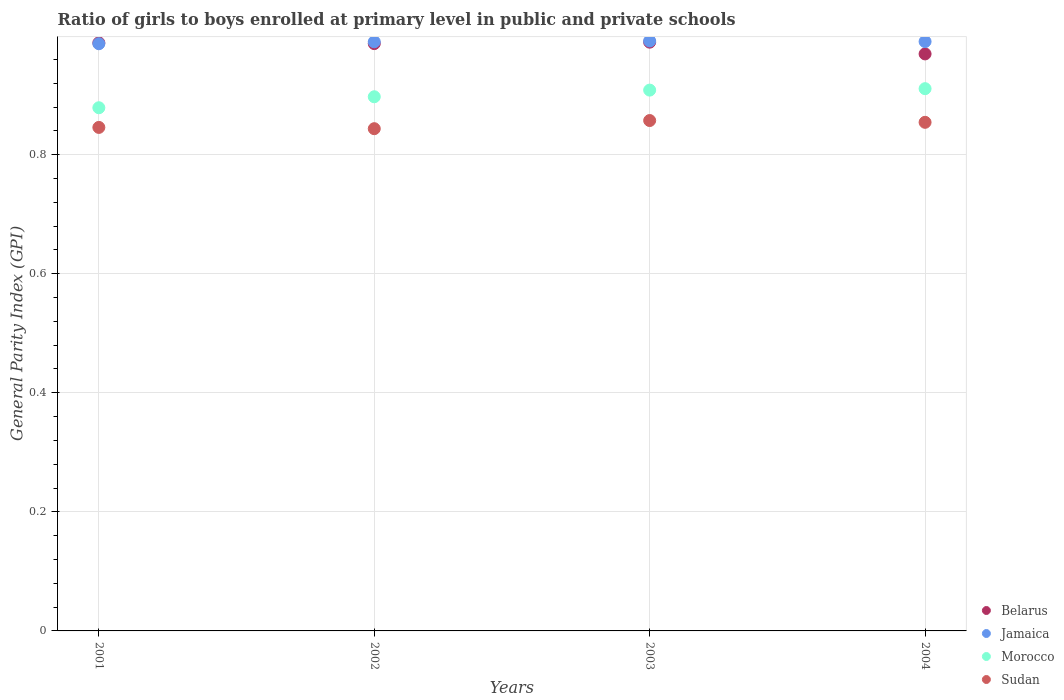Is the number of dotlines equal to the number of legend labels?
Keep it short and to the point. Yes. What is the general parity index in Jamaica in 2004?
Your answer should be compact. 0.99. Across all years, what is the maximum general parity index in Jamaica?
Provide a short and direct response. 0.99. Across all years, what is the minimum general parity index in Jamaica?
Your response must be concise. 0.99. What is the total general parity index in Jamaica in the graph?
Provide a succinct answer. 3.96. What is the difference between the general parity index in Sudan in 2002 and that in 2004?
Give a very brief answer. -0.01. What is the difference between the general parity index in Morocco in 2003 and the general parity index in Jamaica in 2001?
Your answer should be compact. -0.08. What is the average general parity index in Jamaica per year?
Your answer should be very brief. 0.99. In the year 2003, what is the difference between the general parity index in Jamaica and general parity index in Sudan?
Ensure brevity in your answer.  0.13. What is the ratio of the general parity index in Morocco in 2002 to that in 2004?
Your answer should be compact. 0.99. Is the difference between the general parity index in Jamaica in 2002 and 2003 greater than the difference between the general parity index in Sudan in 2002 and 2003?
Make the answer very short. Yes. What is the difference between the highest and the second highest general parity index in Sudan?
Your answer should be compact. 0. What is the difference between the highest and the lowest general parity index in Jamaica?
Offer a very short reply. 0. Is the sum of the general parity index in Sudan in 2003 and 2004 greater than the maximum general parity index in Morocco across all years?
Give a very brief answer. Yes. Is it the case that in every year, the sum of the general parity index in Morocco and general parity index in Belarus  is greater than the general parity index in Jamaica?
Your answer should be compact. Yes. Is the general parity index in Jamaica strictly greater than the general parity index in Belarus over the years?
Make the answer very short. No. What is the difference between two consecutive major ticks on the Y-axis?
Ensure brevity in your answer.  0.2. Are the values on the major ticks of Y-axis written in scientific E-notation?
Offer a very short reply. No. Does the graph contain any zero values?
Ensure brevity in your answer.  No. What is the title of the graph?
Your answer should be compact. Ratio of girls to boys enrolled at primary level in public and private schools. What is the label or title of the X-axis?
Provide a short and direct response. Years. What is the label or title of the Y-axis?
Give a very brief answer. General Parity Index (GPI). What is the General Parity Index (GPI) in Belarus in 2001?
Your answer should be very brief. 0.99. What is the General Parity Index (GPI) of Jamaica in 2001?
Ensure brevity in your answer.  0.99. What is the General Parity Index (GPI) of Morocco in 2001?
Provide a succinct answer. 0.88. What is the General Parity Index (GPI) of Sudan in 2001?
Provide a short and direct response. 0.85. What is the General Parity Index (GPI) of Belarus in 2002?
Provide a short and direct response. 0.99. What is the General Parity Index (GPI) in Jamaica in 2002?
Your answer should be very brief. 0.99. What is the General Parity Index (GPI) in Morocco in 2002?
Give a very brief answer. 0.9. What is the General Parity Index (GPI) in Sudan in 2002?
Provide a succinct answer. 0.84. What is the General Parity Index (GPI) of Belarus in 2003?
Provide a succinct answer. 0.99. What is the General Parity Index (GPI) in Jamaica in 2003?
Your response must be concise. 0.99. What is the General Parity Index (GPI) in Morocco in 2003?
Provide a succinct answer. 0.91. What is the General Parity Index (GPI) of Sudan in 2003?
Keep it short and to the point. 0.86. What is the General Parity Index (GPI) in Belarus in 2004?
Provide a succinct answer. 0.97. What is the General Parity Index (GPI) in Jamaica in 2004?
Your answer should be compact. 0.99. What is the General Parity Index (GPI) of Morocco in 2004?
Offer a very short reply. 0.91. What is the General Parity Index (GPI) in Sudan in 2004?
Keep it short and to the point. 0.85. Across all years, what is the maximum General Parity Index (GPI) in Belarus?
Make the answer very short. 0.99. Across all years, what is the maximum General Parity Index (GPI) of Jamaica?
Your answer should be very brief. 0.99. Across all years, what is the maximum General Parity Index (GPI) in Morocco?
Keep it short and to the point. 0.91. Across all years, what is the maximum General Parity Index (GPI) in Sudan?
Provide a short and direct response. 0.86. Across all years, what is the minimum General Parity Index (GPI) in Belarus?
Your answer should be very brief. 0.97. Across all years, what is the minimum General Parity Index (GPI) in Jamaica?
Provide a short and direct response. 0.99. Across all years, what is the minimum General Parity Index (GPI) of Morocco?
Your answer should be very brief. 0.88. Across all years, what is the minimum General Parity Index (GPI) of Sudan?
Provide a short and direct response. 0.84. What is the total General Parity Index (GPI) in Belarus in the graph?
Keep it short and to the point. 3.93. What is the total General Parity Index (GPI) in Jamaica in the graph?
Offer a very short reply. 3.96. What is the total General Parity Index (GPI) in Morocco in the graph?
Your response must be concise. 3.6. What is the total General Parity Index (GPI) of Sudan in the graph?
Your answer should be compact. 3.4. What is the difference between the General Parity Index (GPI) of Belarus in 2001 and that in 2002?
Ensure brevity in your answer.  0. What is the difference between the General Parity Index (GPI) of Jamaica in 2001 and that in 2002?
Give a very brief answer. -0. What is the difference between the General Parity Index (GPI) in Morocco in 2001 and that in 2002?
Your answer should be very brief. -0.02. What is the difference between the General Parity Index (GPI) in Sudan in 2001 and that in 2002?
Provide a short and direct response. 0. What is the difference between the General Parity Index (GPI) in Belarus in 2001 and that in 2003?
Your response must be concise. -0. What is the difference between the General Parity Index (GPI) of Jamaica in 2001 and that in 2003?
Provide a short and direct response. -0. What is the difference between the General Parity Index (GPI) in Morocco in 2001 and that in 2003?
Ensure brevity in your answer.  -0.03. What is the difference between the General Parity Index (GPI) in Sudan in 2001 and that in 2003?
Your response must be concise. -0.01. What is the difference between the General Parity Index (GPI) of Belarus in 2001 and that in 2004?
Keep it short and to the point. 0.02. What is the difference between the General Parity Index (GPI) in Jamaica in 2001 and that in 2004?
Your response must be concise. -0. What is the difference between the General Parity Index (GPI) of Morocco in 2001 and that in 2004?
Offer a terse response. -0.03. What is the difference between the General Parity Index (GPI) in Sudan in 2001 and that in 2004?
Offer a very short reply. -0.01. What is the difference between the General Parity Index (GPI) of Belarus in 2002 and that in 2003?
Your response must be concise. -0. What is the difference between the General Parity Index (GPI) in Jamaica in 2002 and that in 2003?
Offer a terse response. -0. What is the difference between the General Parity Index (GPI) of Morocco in 2002 and that in 2003?
Provide a succinct answer. -0.01. What is the difference between the General Parity Index (GPI) of Sudan in 2002 and that in 2003?
Provide a succinct answer. -0.01. What is the difference between the General Parity Index (GPI) in Belarus in 2002 and that in 2004?
Ensure brevity in your answer.  0.02. What is the difference between the General Parity Index (GPI) of Jamaica in 2002 and that in 2004?
Give a very brief answer. -0. What is the difference between the General Parity Index (GPI) in Morocco in 2002 and that in 2004?
Give a very brief answer. -0.01. What is the difference between the General Parity Index (GPI) in Sudan in 2002 and that in 2004?
Provide a succinct answer. -0.01. What is the difference between the General Parity Index (GPI) of Belarus in 2003 and that in 2004?
Make the answer very short. 0.02. What is the difference between the General Parity Index (GPI) of Morocco in 2003 and that in 2004?
Offer a terse response. -0. What is the difference between the General Parity Index (GPI) of Sudan in 2003 and that in 2004?
Offer a very short reply. 0. What is the difference between the General Parity Index (GPI) in Belarus in 2001 and the General Parity Index (GPI) in Jamaica in 2002?
Your response must be concise. -0. What is the difference between the General Parity Index (GPI) of Belarus in 2001 and the General Parity Index (GPI) of Morocco in 2002?
Provide a short and direct response. 0.09. What is the difference between the General Parity Index (GPI) of Belarus in 2001 and the General Parity Index (GPI) of Sudan in 2002?
Provide a succinct answer. 0.14. What is the difference between the General Parity Index (GPI) of Jamaica in 2001 and the General Parity Index (GPI) of Morocco in 2002?
Keep it short and to the point. 0.09. What is the difference between the General Parity Index (GPI) in Jamaica in 2001 and the General Parity Index (GPI) in Sudan in 2002?
Offer a terse response. 0.14. What is the difference between the General Parity Index (GPI) of Morocco in 2001 and the General Parity Index (GPI) of Sudan in 2002?
Provide a succinct answer. 0.04. What is the difference between the General Parity Index (GPI) of Belarus in 2001 and the General Parity Index (GPI) of Jamaica in 2003?
Keep it short and to the point. -0. What is the difference between the General Parity Index (GPI) of Belarus in 2001 and the General Parity Index (GPI) of Morocco in 2003?
Your answer should be compact. 0.08. What is the difference between the General Parity Index (GPI) in Belarus in 2001 and the General Parity Index (GPI) in Sudan in 2003?
Make the answer very short. 0.13. What is the difference between the General Parity Index (GPI) in Jamaica in 2001 and the General Parity Index (GPI) in Morocco in 2003?
Ensure brevity in your answer.  0.08. What is the difference between the General Parity Index (GPI) of Jamaica in 2001 and the General Parity Index (GPI) of Sudan in 2003?
Provide a short and direct response. 0.13. What is the difference between the General Parity Index (GPI) of Morocco in 2001 and the General Parity Index (GPI) of Sudan in 2003?
Keep it short and to the point. 0.02. What is the difference between the General Parity Index (GPI) in Belarus in 2001 and the General Parity Index (GPI) in Jamaica in 2004?
Your answer should be compact. -0. What is the difference between the General Parity Index (GPI) in Belarus in 2001 and the General Parity Index (GPI) in Morocco in 2004?
Offer a terse response. 0.08. What is the difference between the General Parity Index (GPI) in Belarus in 2001 and the General Parity Index (GPI) in Sudan in 2004?
Your answer should be compact. 0.13. What is the difference between the General Parity Index (GPI) of Jamaica in 2001 and the General Parity Index (GPI) of Morocco in 2004?
Offer a terse response. 0.08. What is the difference between the General Parity Index (GPI) of Jamaica in 2001 and the General Parity Index (GPI) of Sudan in 2004?
Your answer should be compact. 0.13. What is the difference between the General Parity Index (GPI) of Morocco in 2001 and the General Parity Index (GPI) of Sudan in 2004?
Your response must be concise. 0.02. What is the difference between the General Parity Index (GPI) of Belarus in 2002 and the General Parity Index (GPI) of Jamaica in 2003?
Offer a terse response. -0. What is the difference between the General Parity Index (GPI) in Belarus in 2002 and the General Parity Index (GPI) in Morocco in 2003?
Your answer should be very brief. 0.08. What is the difference between the General Parity Index (GPI) in Belarus in 2002 and the General Parity Index (GPI) in Sudan in 2003?
Your response must be concise. 0.13. What is the difference between the General Parity Index (GPI) in Jamaica in 2002 and the General Parity Index (GPI) in Morocco in 2003?
Offer a very short reply. 0.08. What is the difference between the General Parity Index (GPI) of Jamaica in 2002 and the General Parity Index (GPI) of Sudan in 2003?
Keep it short and to the point. 0.13. What is the difference between the General Parity Index (GPI) of Morocco in 2002 and the General Parity Index (GPI) of Sudan in 2003?
Give a very brief answer. 0.04. What is the difference between the General Parity Index (GPI) of Belarus in 2002 and the General Parity Index (GPI) of Jamaica in 2004?
Give a very brief answer. -0. What is the difference between the General Parity Index (GPI) of Belarus in 2002 and the General Parity Index (GPI) of Morocco in 2004?
Your answer should be compact. 0.08. What is the difference between the General Parity Index (GPI) of Belarus in 2002 and the General Parity Index (GPI) of Sudan in 2004?
Your answer should be compact. 0.13. What is the difference between the General Parity Index (GPI) in Jamaica in 2002 and the General Parity Index (GPI) in Morocco in 2004?
Provide a succinct answer. 0.08. What is the difference between the General Parity Index (GPI) in Jamaica in 2002 and the General Parity Index (GPI) in Sudan in 2004?
Give a very brief answer. 0.14. What is the difference between the General Parity Index (GPI) of Morocco in 2002 and the General Parity Index (GPI) of Sudan in 2004?
Provide a succinct answer. 0.04. What is the difference between the General Parity Index (GPI) of Belarus in 2003 and the General Parity Index (GPI) of Jamaica in 2004?
Make the answer very short. -0. What is the difference between the General Parity Index (GPI) in Belarus in 2003 and the General Parity Index (GPI) in Morocco in 2004?
Your answer should be very brief. 0.08. What is the difference between the General Parity Index (GPI) in Belarus in 2003 and the General Parity Index (GPI) in Sudan in 2004?
Keep it short and to the point. 0.13. What is the difference between the General Parity Index (GPI) of Jamaica in 2003 and the General Parity Index (GPI) of Morocco in 2004?
Provide a succinct answer. 0.08. What is the difference between the General Parity Index (GPI) of Jamaica in 2003 and the General Parity Index (GPI) of Sudan in 2004?
Make the answer very short. 0.14. What is the difference between the General Parity Index (GPI) of Morocco in 2003 and the General Parity Index (GPI) of Sudan in 2004?
Ensure brevity in your answer.  0.05. What is the average General Parity Index (GPI) of Belarus per year?
Make the answer very short. 0.98. What is the average General Parity Index (GPI) of Morocco per year?
Provide a short and direct response. 0.9. What is the average General Parity Index (GPI) in Sudan per year?
Provide a short and direct response. 0.85. In the year 2001, what is the difference between the General Parity Index (GPI) in Belarus and General Parity Index (GPI) in Jamaica?
Your answer should be very brief. 0. In the year 2001, what is the difference between the General Parity Index (GPI) in Belarus and General Parity Index (GPI) in Morocco?
Offer a terse response. 0.11. In the year 2001, what is the difference between the General Parity Index (GPI) of Belarus and General Parity Index (GPI) of Sudan?
Offer a terse response. 0.14. In the year 2001, what is the difference between the General Parity Index (GPI) in Jamaica and General Parity Index (GPI) in Morocco?
Offer a terse response. 0.11. In the year 2001, what is the difference between the General Parity Index (GPI) of Jamaica and General Parity Index (GPI) of Sudan?
Provide a short and direct response. 0.14. In the year 2001, what is the difference between the General Parity Index (GPI) in Morocco and General Parity Index (GPI) in Sudan?
Your answer should be compact. 0.03. In the year 2002, what is the difference between the General Parity Index (GPI) in Belarus and General Parity Index (GPI) in Jamaica?
Your response must be concise. -0. In the year 2002, what is the difference between the General Parity Index (GPI) of Belarus and General Parity Index (GPI) of Morocco?
Provide a short and direct response. 0.09. In the year 2002, what is the difference between the General Parity Index (GPI) of Belarus and General Parity Index (GPI) of Sudan?
Give a very brief answer. 0.14. In the year 2002, what is the difference between the General Parity Index (GPI) of Jamaica and General Parity Index (GPI) of Morocco?
Ensure brevity in your answer.  0.09. In the year 2002, what is the difference between the General Parity Index (GPI) in Jamaica and General Parity Index (GPI) in Sudan?
Offer a terse response. 0.15. In the year 2002, what is the difference between the General Parity Index (GPI) in Morocco and General Parity Index (GPI) in Sudan?
Provide a short and direct response. 0.05. In the year 2003, what is the difference between the General Parity Index (GPI) of Belarus and General Parity Index (GPI) of Jamaica?
Offer a terse response. -0. In the year 2003, what is the difference between the General Parity Index (GPI) of Belarus and General Parity Index (GPI) of Morocco?
Ensure brevity in your answer.  0.08. In the year 2003, what is the difference between the General Parity Index (GPI) in Belarus and General Parity Index (GPI) in Sudan?
Ensure brevity in your answer.  0.13. In the year 2003, what is the difference between the General Parity Index (GPI) of Jamaica and General Parity Index (GPI) of Morocco?
Your answer should be very brief. 0.08. In the year 2003, what is the difference between the General Parity Index (GPI) of Jamaica and General Parity Index (GPI) of Sudan?
Provide a short and direct response. 0.13. In the year 2003, what is the difference between the General Parity Index (GPI) in Morocco and General Parity Index (GPI) in Sudan?
Your response must be concise. 0.05. In the year 2004, what is the difference between the General Parity Index (GPI) of Belarus and General Parity Index (GPI) of Jamaica?
Provide a short and direct response. -0.02. In the year 2004, what is the difference between the General Parity Index (GPI) of Belarus and General Parity Index (GPI) of Morocco?
Offer a very short reply. 0.06. In the year 2004, what is the difference between the General Parity Index (GPI) of Belarus and General Parity Index (GPI) of Sudan?
Ensure brevity in your answer.  0.11. In the year 2004, what is the difference between the General Parity Index (GPI) of Jamaica and General Parity Index (GPI) of Morocco?
Your answer should be compact. 0.08. In the year 2004, what is the difference between the General Parity Index (GPI) of Jamaica and General Parity Index (GPI) of Sudan?
Give a very brief answer. 0.14. In the year 2004, what is the difference between the General Parity Index (GPI) in Morocco and General Parity Index (GPI) in Sudan?
Your response must be concise. 0.06. What is the ratio of the General Parity Index (GPI) in Belarus in 2001 to that in 2002?
Offer a very short reply. 1. What is the ratio of the General Parity Index (GPI) of Morocco in 2001 to that in 2002?
Offer a very short reply. 0.98. What is the ratio of the General Parity Index (GPI) of Sudan in 2001 to that in 2002?
Offer a very short reply. 1. What is the ratio of the General Parity Index (GPI) in Belarus in 2001 to that in 2003?
Keep it short and to the point. 1. What is the ratio of the General Parity Index (GPI) of Jamaica in 2001 to that in 2003?
Keep it short and to the point. 1. What is the ratio of the General Parity Index (GPI) of Morocco in 2001 to that in 2003?
Keep it short and to the point. 0.97. What is the ratio of the General Parity Index (GPI) in Sudan in 2001 to that in 2003?
Your answer should be very brief. 0.99. What is the ratio of the General Parity Index (GPI) in Belarus in 2001 to that in 2004?
Offer a terse response. 1.02. What is the ratio of the General Parity Index (GPI) of Jamaica in 2001 to that in 2004?
Ensure brevity in your answer.  1. What is the ratio of the General Parity Index (GPI) in Morocco in 2001 to that in 2004?
Keep it short and to the point. 0.96. What is the ratio of the General Parity Index (GPI) of Belarus in 2002 to that in 2003?
Provide a succinct answer. 1. What is the ratio of the General Parity Index (GPI) in Sudan in 2002 to that in 2003?
Your answer should be very brief. 0.98. What is the ratio of the General Parity Index (GPI) in Belarus in 2002 to that in 2004?
Offer a terse response. 1.02. What is the ratio of the General Parity Index (GPI) of Morocco in 2002 to that in 2004?
Give a very brief answer. 0.99. What is the ratio of the General Parity Index (GPI) of Sudan in 2002 to that in 2004?
Offer a terse response. 0.99. What is the ratio of the General Parity Index (GPI) of Belarus in 2003 to that in 2004?
Your answer should be compact. 1.02. What is the ratio of the General Parity Index (GPI) of Jamaica in 2003 to that in 2004?
Make the answer very short. 1. What is the difference between the highest and the second highest General Parity Index (GPI) in Belarus?
Make the answer very short. 0. What is the difference between the highest and the second highest General Parity Index (GPI) in Jamaica?
Keep it short and to the point. 0. What is the difference between the highest and the second highest General Parity Index (GPI) of Morocco?
Your answer should be compact. 0. What is the difference between the highest and the second highest General Parity Index (GPI) of Sudan?
Keep it short and to the point. 0. What is the difference between the highest and the lowest General Parity Index (GPI) of Belarus?
Your answer should be compact. 0.02. What is the difference between the highest and the lowest General Parity Index (GPI) of Jamaica?
Your response must be concise. 0. What is the difference between the highest and the lowest General Parity Index (GPI) of Morocco?
Make the answer very short. 0.03. What is the difference between the highest and the lowest General Parity Index (GPI) of Sudan?
Your answer should be compact. 0.01. 